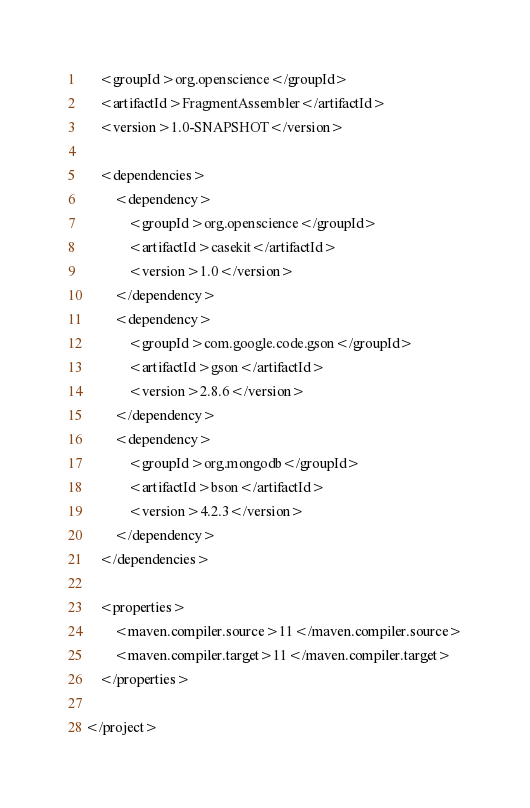Convert code to text. <code><loc_0><loc_0><loc_500><loc_500><_XML_>
    <groupId>org.openscience</groupId>
    <artifactId>FragmentAssembler</artifactId>
    <version>1.0-SNAPSHOT</version>

    <dependencies>
        <dependency>
            <groupId>org.openscience</groupId>
            <artifactId>casekit</artifactId>
            <version>1.0</version>
        </dependency>
        <dependency>
            <groupId>com.google.code.gson</groupId>
            <artifactId>gson</artifactId>
            <version>2.8.6</version>
        </dependency>
        <dependency>
            <groupId>org.mongodb</groupId>
            <artifactId>bson</artifactId>
            <version>4.2.3</version>
        </dependency>
    </dependencies>

    <properties>
        <maven.compiler.source>11</maven.compiler.source>
        <maven.compiler.target>11</maven.compiler.target>
    </properties>

</project></code> 